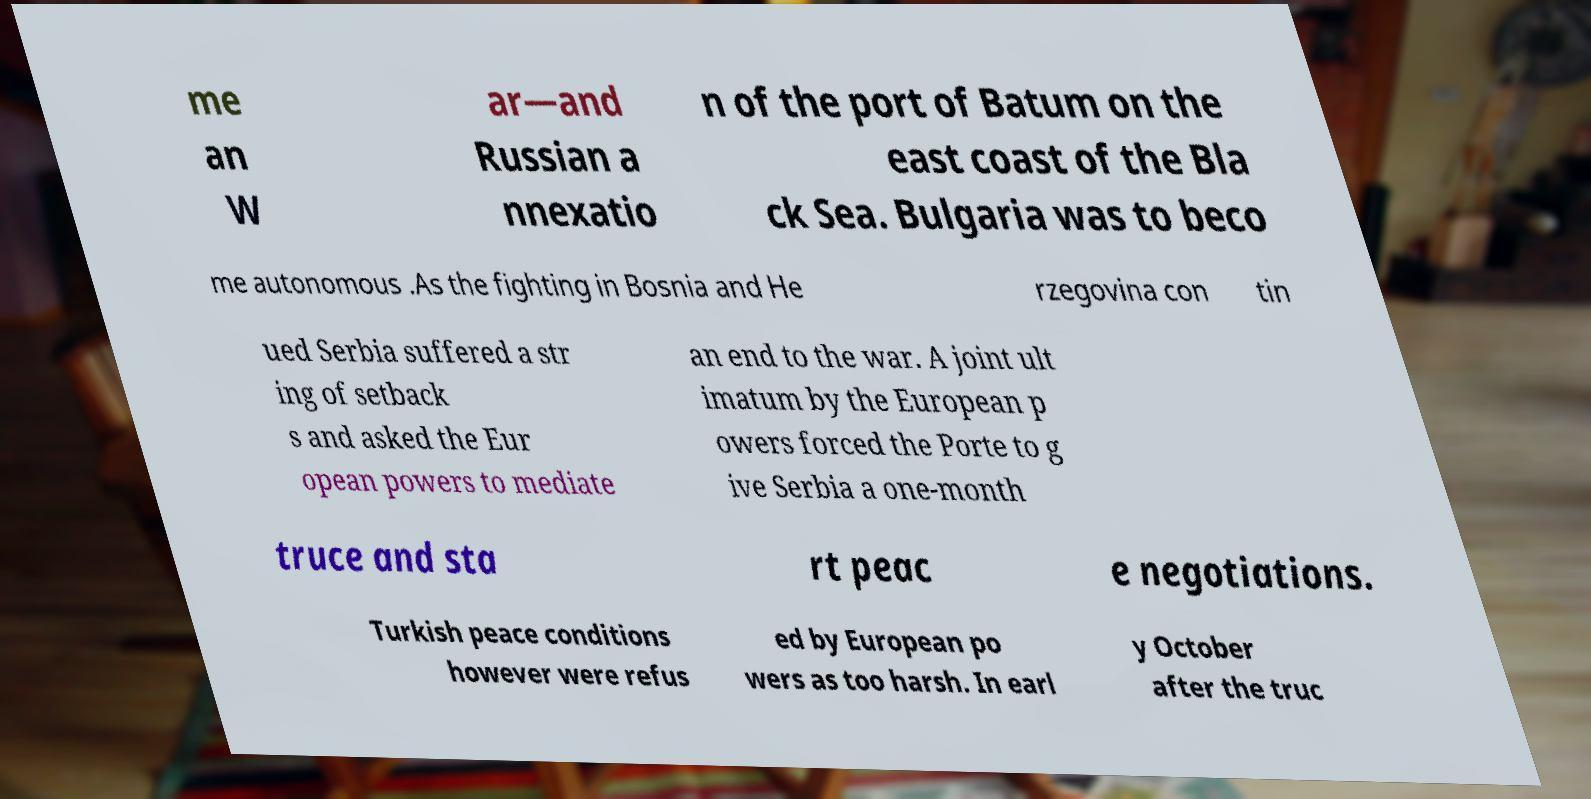I need the written content from this picture converted into text. Can you do that? me an W ar—and Russian a nnexatio n of the port of Batum on the east coast of the Bla ck Sea. Bulgaria was to beco me autonomous .As the fighting in Bosnia and He rzegovina con tin ued Serbia suffered a str ing of setback s and asked the Eur opean powers to mediate an end to the war. A joint ult imatum by the European p owers forced the Porte to g ive Serbia a one-month truce and sta rt peac e negotiations. Turkish peace conditions however were refus ed by European po wers as too harsh. In earl y October after the truc 